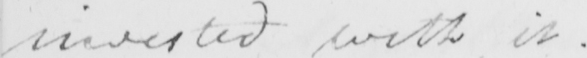Can you tell me what this handwritten text says? invested with it . 